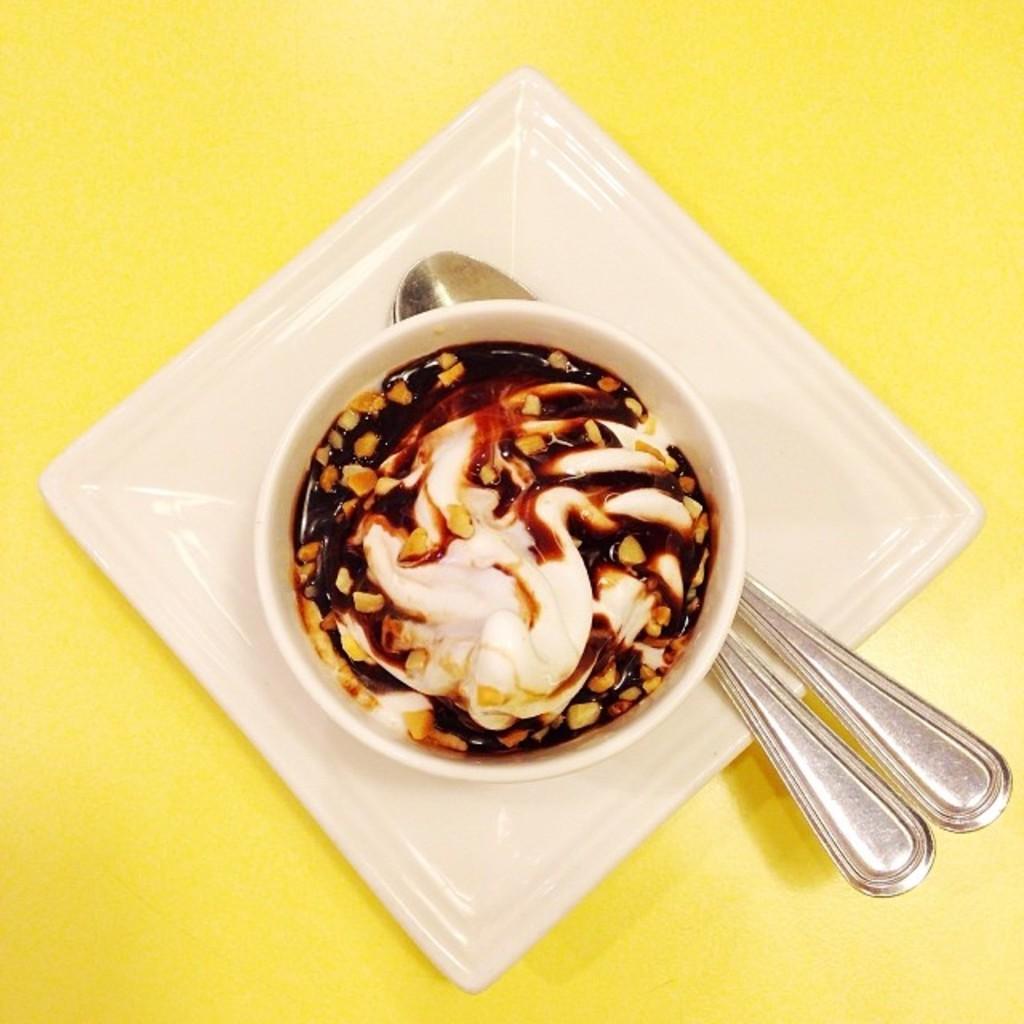Could you give a brief overview of what you see in this image? This image consists of a food in a bowl. At the bottom, we can see the spoons on the plate. It is kept on the desk which is in yellow color. 